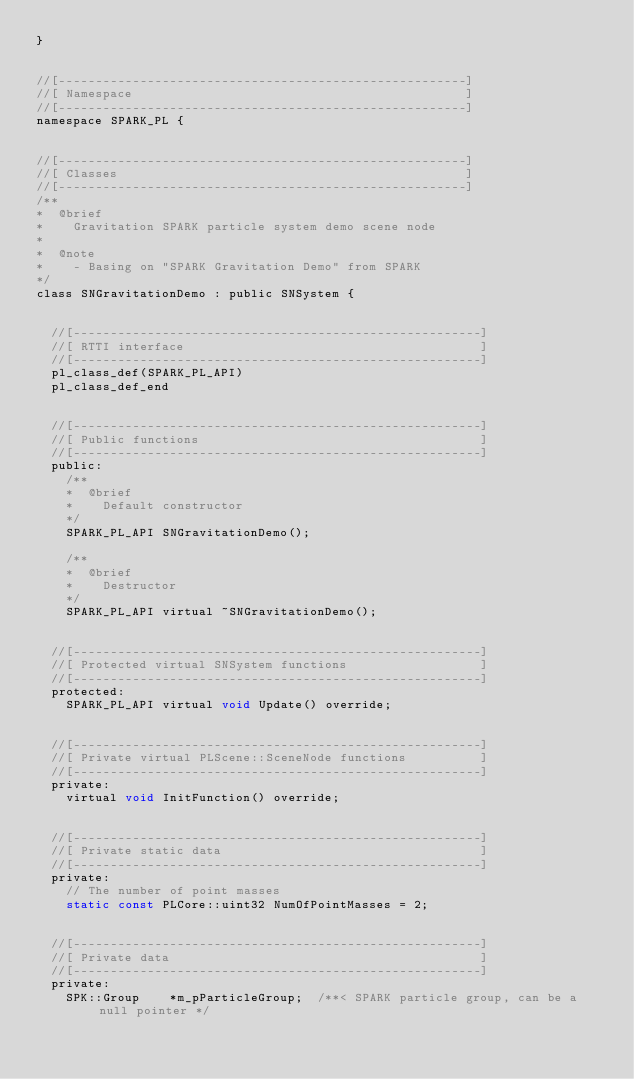<code> <loc_0><loc_0><loc_500><loc_500><_C_>}


//[-------------------------------------------------------]
//[ Namespace                                             ]
//[-------------------------------------------------------]
namespace SPARK_PL {


//[-------------------------------------------------------]
//[ Classes                                               ]
//[-------------------------------------------------------]
/**
*  @brief
*    Gravitation SPARK particle system demo scene node
*
*  @note
*    - Basing on "SPARK Gravitation Demo" from SPARK
*/
class SNGravitationDemo : public SNSystem {


	//[-------------------------------------------------------]
	//[ RTTI interface                                        ]
	//[-------------------------------------------------------]
	pl_class_def(SPARK_PL_API)
	pl_class_def_end


	//[-------------------------------------------------------]
	//[ Public functions                                      ]
	//[-------------------------------------------------------]
	public:
		/**
		*  @brief
		*    Default constructor
		*/
		SPARK_PL_API SNGravitationDemo();

		/**
		*  @brief
		*    Destructor
		*/
		SPARK_PL_API virtual ~SNGravitationDemo();


	//[-------------------------------------------------------]
	//[ Protected virtual SNSystem functions                  ]
	//[-------------------------------------------------------]
	protected:
		SPARK_PL_API virtual void Update() override;


	//[-------------------------------------------------------]
	//[ Private virtual PLScene::SceneNode functions          ]
	//[-------------------------------------------------------]
	private:
		virtual void InitFunction() override;


	//[-------------------------------------------------------]
	//[ Private static data                                   ]
	//[-------------------------------------------------------]
	private:
		// The number of point masses
		static const PLCore::uint32 NumOfPointMasses = 2;


	//[-------------------------------------------------------]
	//[ Private data                                          ]
	//[-------------------------------------------------------]
	private:
		SPK::Group		*m_pParticleGroup;	/**< SPARK particle group, can be a null pointer */</code> 